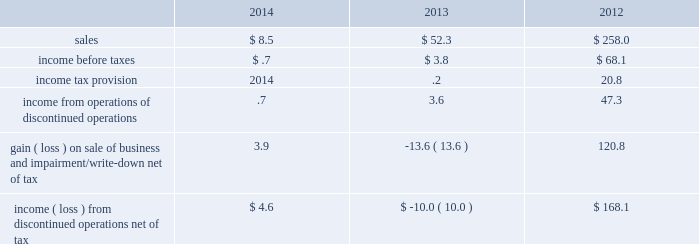Discontinued operations during the second quarter of 2012 , the board of directors authorized the sale of our homecare business , which had previously been reported as part of the merchant gases operating segment .
This business has been accounted for as a discontinued operation .
In the third quarter of 2012 , we sold the majority of our homecare business to the linde group for sale proceeds of 20ac590 million ( $ 777 ) and recognized a gain of $ 207.4 ( $ 150.3 after-tax , or $ .70 per share ) .
The sale proceeds included 20ac110 million ( $ 144 ) that was contingent on the outcome of certain retender arrangements .
These proceeds were reflected in payables and accrued liabilities on our consolidated balance sheet as of 30 september 2013 .
Based on the outcome of the retenders , we were contractually required to return proceeds to the linde group .
In the fourth quarter of 2014 , we made a payment to settle this liability and recognized a gain of $ 1.5 .
During the third quarter of 2012 , an impairment charge of $ 33.5 ( $ 29.5 after-tax , or $ .14 per share ) was recorded to write down the remaining business , which was primarily in the united kingdom and ireland , to its estimated net realizable value .
In the fourth quarter of 2013 , an additional charge of $ 18.7 ( $ 13.6 after-tax , or $ .06 per share ) was recorded to update our estimate of the net realizable value .
In the first quarter of 2014 , we sold the remaining portion of the homecare business for a36.1 million ( $ 9.8 ) and recorded a gain on sale of $ 2.4 .
We entered into an operations guarantee related to the obligations under certain homecare contracts assigned in connection with the transaction .
Refer to note 16 , commitments and contingencies , for additional information .
The results of discontinued operations are summarized below: .
The assets and liabilities classified as discontinued operations for the homecare business at 30 september 2013 consisted of $ 2.5 in trade receivables , net , and $ 2.4 in payables and accrued liabilities .
As of 30 september 2014 , no assets or liabilities were classified as discontinued operations. .
What was the decrease observed in the sales during 2013 and 2014? 
Rationale: it is the percentual variation observed , which is calculated using the initial value ( 52.3 ) and the final value ( 8.5 ) then turned into a percentage .
Computations: ((8.5 - 52.3) / 52.3)
Answer: -0.83748. 